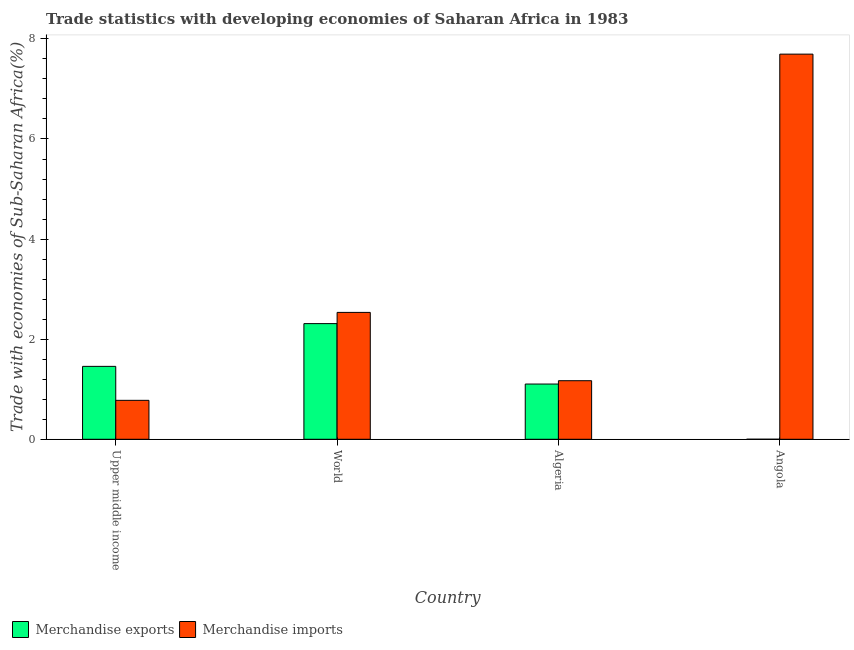How many different coloured bars are there?
Provide a succinct answer. 2. How many groups of bars are there?
Provide a short and direct response. 4. What is the label of the 1st group of bars from the left?
Make the answer very short. Upper middle income. What is the merchandise imports in Algeria?
Provide a succinct answer. 1.17. Across all countries, what is the maximum merchandise exports?
Offer a terse response. 2.31. Across all countries, what is the minimum merchandise imports?
Your answer should be compact. 0.78. In which country was the merchandise imports maximum?
Offer a very short reply. Angola. In which country was the merchandise imports minimum?
Keep it short and to the point. Upper middle income. What is the total merchandise imports in the graph?
Make the answer very short. 12.18. What is the difference between the merchandise imports in Angola and that in World?
Provide a short and direct response. 5.16. What is the difference between the merchandise exports in Algeria and the merchandise imports in World?
Your answer should be very brief. -1.43. What is the average merchandise exports per country?
Ensure brevity in your answer.  1.22. What is the difference between the merchandise imports and merchandise exports in Algeria?
Make the answer very short. 0.07. In how many countries, is the merchandise imports greater than 2 %?
Give a very brief answer. 2. What is the ratio of the merchandise imports in Angola to that in World?
Provide a short and direct response. 3.04. Is the merchandise imports in Angola less than that in World?
Your answer should be compact. No. What is the difference between the highest and the second highest merchandise exports?
Your answer should be very brief. 0.85. What is the difference between the highest and the lowest merchandise imports?
Provide a short and direct response. 6.92. Is the sum of the merchandise imports in Algeria and Upper middle income greater than the maximum merchandise exports across all countries?
Offer a very short reply. No. What does the 1st bar from the left in World represents?
Make the answer very short. Merchandise exports. How many countries are there in the graph?
Your answer should be compact. 4. What is the difference between two consecutive major ticks on the Y-axis?
Your answer should be very brief. 2. Does the graph contain any zero values?
Ensure brevity in your answer.  No. Does the graph contain grids?
Keep it short and to the point. No. Where does the legend appear in the graph?
Give a very brief answer. Bottom left. How are the legend labels stacked?
Your answer should be compact. Horizontal. What is the title of the graph?
Keep it short and to the point. Trade statistics with developing economies of Saharan Africa in 1983. What is the label or title of the Y-axis?
Give a very brief answer. Trade with economies of Sub-Saharan Africa(%). What is the Trade with economies of Sub-Saharan Africa(%) of Merchandise exports in Upper middle income?
Your answer should be very brief. 1.46. What is the Trade with economies of Sub-Saharan Africa(%) in Merchandise imports in Upper middle income?
Your response must be concise. 0.78. What is the Trade with economies of Sub-Saharan Africa(%) in Merchandise exports in World?
Offer a terse response. 2.31. What is the Trade with economies of Sub-Saharan Africa(%) in Merchandise imports in World?
Give a very brief answer. 2.54. What is the Trade with economies of Sub-Saharan Africa(%) of Merchandise exports in Algeria?
Provide a succinct answer. 1.1. What is the Trade with economies of Sub-Saharan Africa(%) in Merchandise imports in Algeria?
Your response must be concise. 1.17. What is the Trade with economies of Sub-Saharan Africa(%) of Merchandise exports in Angola?
Provide a succinct answer. 0. What is the Trade with economies of Sub-Saharan Africa(%) in Merchandise imports in Angola?
Provide a short and direct response. 7.7. Across all countries, what is the maximum Trade with economies of Sub-Saharan Africa(%) of Merchandise exports?
Your response must be concise. 2.31. Across all countries, what is the maximum Trade with economies of Sub-Saharan Africa(%) of Merchandise imports?
Ensure brevity in your answer.  7.7. Across all countries, what is the minimum Trade with economies of Sub-Saharan Africa(%) of Merchandise exports?
Keep it short and to the point. 0. Across all countries, what is the minimum Trade with economies of Sub-Saharan Africa(%) of Merchandise imports?
Your answer should be compact. 0.78. What is the total Trade with economies of Sub-Saharan Africa(%) of Merchandise exports in the graph?
Provide a short and direct response. 4.87. What is the total Trade with economies of Sub-Saharan Africa(%) in Merchandise imports in the graph?
Your answer should be very brief. 12.18. What is the difference between the Trade with economies of Sub-Saharan Africa(%) of Merchandise exports in Upper middle income and that in World?
Your answer should be very brief. -0.85. What is the difference between the Trade with economies of Sub-Saharan Africa(%) of Merchandise imports in Upper middle income and that in World?
Provide a succinct answer. -1.76. What is the difference between the Trade with economies of Sub-Saharan Africa(%) in Merchandise exports in Upper middle income and that in Algeria?
Give a very brief answer. 0.35. What is the difference between the Trade with economies of Sub-Saharan Africa(%) in Merchandise imports in Upper middle income and that in Algeria?
Give a very brief answer. -0.39. What is the difference between the Trade with economies of Sub-Saharan Africa(%) of Merchandise exports in Upper middle income and that in Angola?
Offer a terse response. 1.46. What is the difference between the Trade with economies of Sub-Saharan Africa(%) in Merchandise imports in Upper middle income and that in Angola?
Offer a terse response. -6.92. What is the difference between the Trade with economies of Sub-Saharan Africa(%) of Merchandise exports in World and that in Algeria?
Provide a succinct answer. 1.21. What is the difference between the Trade with economies of Sub-Saharan Africa(%) of Merchandise imports in World and that in Algeria?
Offer a terse response. 1.37. What is the difference between the Trade with economies of Sub-Saharan Africa(%) of Merchandise exports in World and that in Angola?
Offer a terse response. 2.31. What is the difference between the Trade with economies of Sub-Saharan Africa(%) in Merchandise imports in World and that in Angola?
Your answer should be compact. -5.16. What is the difference between the Trade with economies of Sub-Saharan Africa(%) of Merchandise exports in Algeria and that in Angola?
Your answer should be compact. 1.1. What is the difference between the Trade with economies of Sub-Saharan Africa(%) of Merchandise imports in Algeria and that in Angola?
Your response must be concise. -6.53. What is the difference between the Trade with economies of Sub-Saharan Africa(%) in Merchandise exports in Upper middle income and the Trade with economies of Sub-Saharan Africa(%) in Merchandise imports in World?
Offer a very short reply. -1.08. What is the difference between the Trade with economies of Sub-Saharan Africa(%) of Merchandise exports in Upper middle income and the Trade with economies of Sub-Saharan Africa(%) of Merchandise imports in Algeria?
Make the answer very short. 0.29. What is the difference between the Trade with economies of Sub-Saharan Africa(%) in Merchandise exports in Upper middle income and the Trade with economies of Sub-Saharan Africa(%) in Merchandise imports in Angola?
Your response must be concise. -6.24. What is the difference between the Trade with economies of Sub-Saharan Africa(%) of Merchandise exports in World and the Trade with economies of Sub-Saharan Africa(%) of Merchandise imports in Algeria?
Your answer should be compact. 1.14. What is the difference between the Trade with economies of Sub-Saharan Africa(%) of Merchandise exports in World and the Trade with economies of Sub-Saharan Africa(%) of Merchandise imports in Angola?
Give a very brief answer. -5.38. What is the difference between the Trade with economies of Sub-Saharan Africa(%) in Merchandise exports in Algeria and the Trade with economies of Sub-Saharan Africa(%) in Merchandise imports in Angola?
Make the answer very short. -6.59. What is the average Trade with economies of Sub-Saharan Africa(%) in Merchandise exports per country?
Your response must be concise. 1.22. What is the average Trade with economies of Sub-Saharan Africa(%) in Merchandise imports per country?
Provide a succinct answer. 3.04. What is the difference between the Trade with economies of Sub-Saharan Africa(%) of Merchandise exports and Trade with economies of Sub-Saharan Africa(%) of Merchandise imports in Upper middle income?
Your answer should be compact. 0.68. What is the difference between the Trade with economies of Sub-Saharan Africa(%) of Merchandise exports and Trade with economies of Sub-Saharan Africa(%) of Merchandise imports in World?
Your response must be concise. -0.22. What is the difference between the Trade with economies of Sub-Saharan Africa(%) of Merchandise exports and Trade with economies of Sub-Saharan Africa(%) of Merchandise imports in Algeria?
Offer a terse response. -0.07. What is the difference between the Trade with economies of Sub-Saharan Africa(%) of Merchandise exports and Trade with economies of Sub-Saharan Africa(%) of Merchandise imports in Angola?
Offer a very short reply. -7.7. What is the ratio of the Trade with economies of Sub-Saharan Africa(%) in Merchandise exports in Upper middle income to that in World?
Provide a succinct answer. 0.63. What is the ratio of the Trade with economies of Sub-Saharan Africa(%) in Merchandise imports in Upper middle income to that in World?
Your answer should be compact. 0.31. What is the ratio of the Trade with economies of Sub-Saharan Africa(%) of Merchandise exports in Upper middle income to that in Algeria?
Your answer should be very brief. 1.32. What is the ratio of the Trade with economies of Sub-Saharan Africa(%) in Merchandise imports in Upper middle income to that in Algeria?
Your response must be concise. 0.67. What is the ratio of the Trade with economies of Sub-Saharan Africa(%) of Merchandise exports in Upper middle income to that in Angola?
Provide a short and direct response. 2536.72. What is the ratio of the Trade with economies of Sub-Saharan Africa(%) in Merchandise imports in Upper middle income to that in Angola?
Offer a terse response. 0.1. What is the ratio of the Trade with economies of Sub-Saharan Africa(%) of Merchandise exports in World to that in Algeria?
Make the answer very short. 2.09. What is the ratio of the Trade with economies of Sub-Saharan Africa(%) of Merchandise imports in World to that in Algeria?
Keep it short and to the point. 2.17. What is the ratio of the Trade with economies of Sub-Saharan Africa(%) in Merchandise exports in World to that in Angola?
Your answer should be compact. 4024.15. What is the ratio of the Trade with economies of Sub-Saharan Africa(%) in Merchandise imports in World to that in Angola?
Offer a terse response. 0.33. What is the ratio of the Trade with economies of Sub-Saharan Africa(%) of Merchandise exports in Algeria to that in Angola?
Keep it short and to the point. 1921.66. What is the ratio of the Trade with economies of Sub-Saharan Africa(%) of Merchandise imports in Algeria to that in Angola?
Give a very brief answer. 0.15. What is the difference between the highest and the second highest Trade with economies of Sub-Saharan Africa(%) of Merchandise exports?
Make the answer very short. 0.85. What is the difference between the highest and the second highest Trade with economies of Sub-Saharan Africa(%) in Merchandise imports?
Keep it short and to the point. 5.16. What is the difference between the highest and the lowest Trade with economies of Sub-Saharan Africa(%) of Merchandise exports?
Your answer should be compact. 2.31. What is the difference between the highest and the lowest Trade with economies of Sub-Saharan Africa(%) in Merchandise imports?
Your answer should be compact. 6.92. 